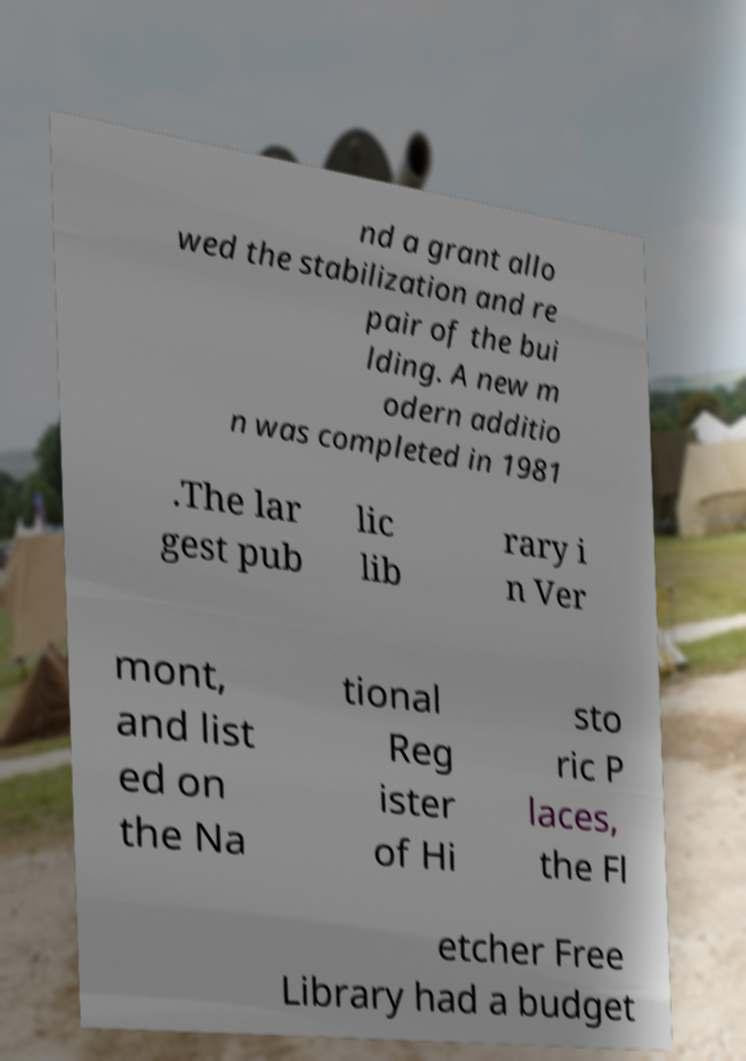For documentation purposes, I need the text within this image transcribed. Could you provide that? nd a grant allo wed the stabilization and re pair of the bui lding. A new m odern additio n was completed in 1981 .The lar gest pub lic lib rary i n Ver mont, and list ed on the Na tional Reg ister of Hi sto ric P laces, the Fl etcher Free Library had a budget 